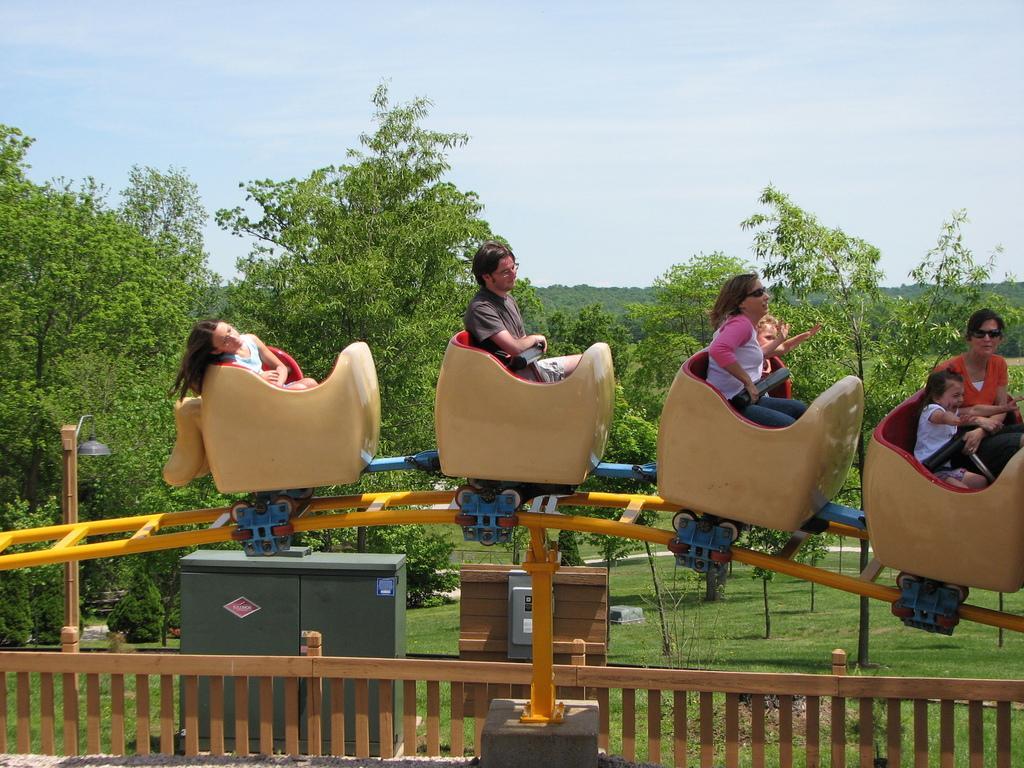In one or two sentences, can you explain what this image depicts? This picture is clicked outside. In the foreground we can see a wooden fence. In the center we can see the group of people sitting in the amusement ride. In the background we the sky, trees, plants, green grass and a cabinet and some wooden objects. 